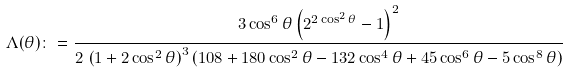<formula> <loc_0><loc_0><loc_500><loc_500>\Lambda ( \theta ) \colon = \frac { 3 \cos ^ { 6 } \theta \left ( 2 ^ { 2 \cos ^ { 2 } \theta } - 1 \right ) ^ { 2 } } { 2 \, \left ( 1 + 2 \cos ^ { 2 } \theta \right ) ^ { 3 } \left ( 1 0 8 + 1 8 0 \cos ^ { 2 } \theta - 1 3 2 \cos ^ { 4 } \theta + 4 5 \cos ^ { 6 } \theta - 5 \cos ^ { 8 } \theta \right ) }</formula> 